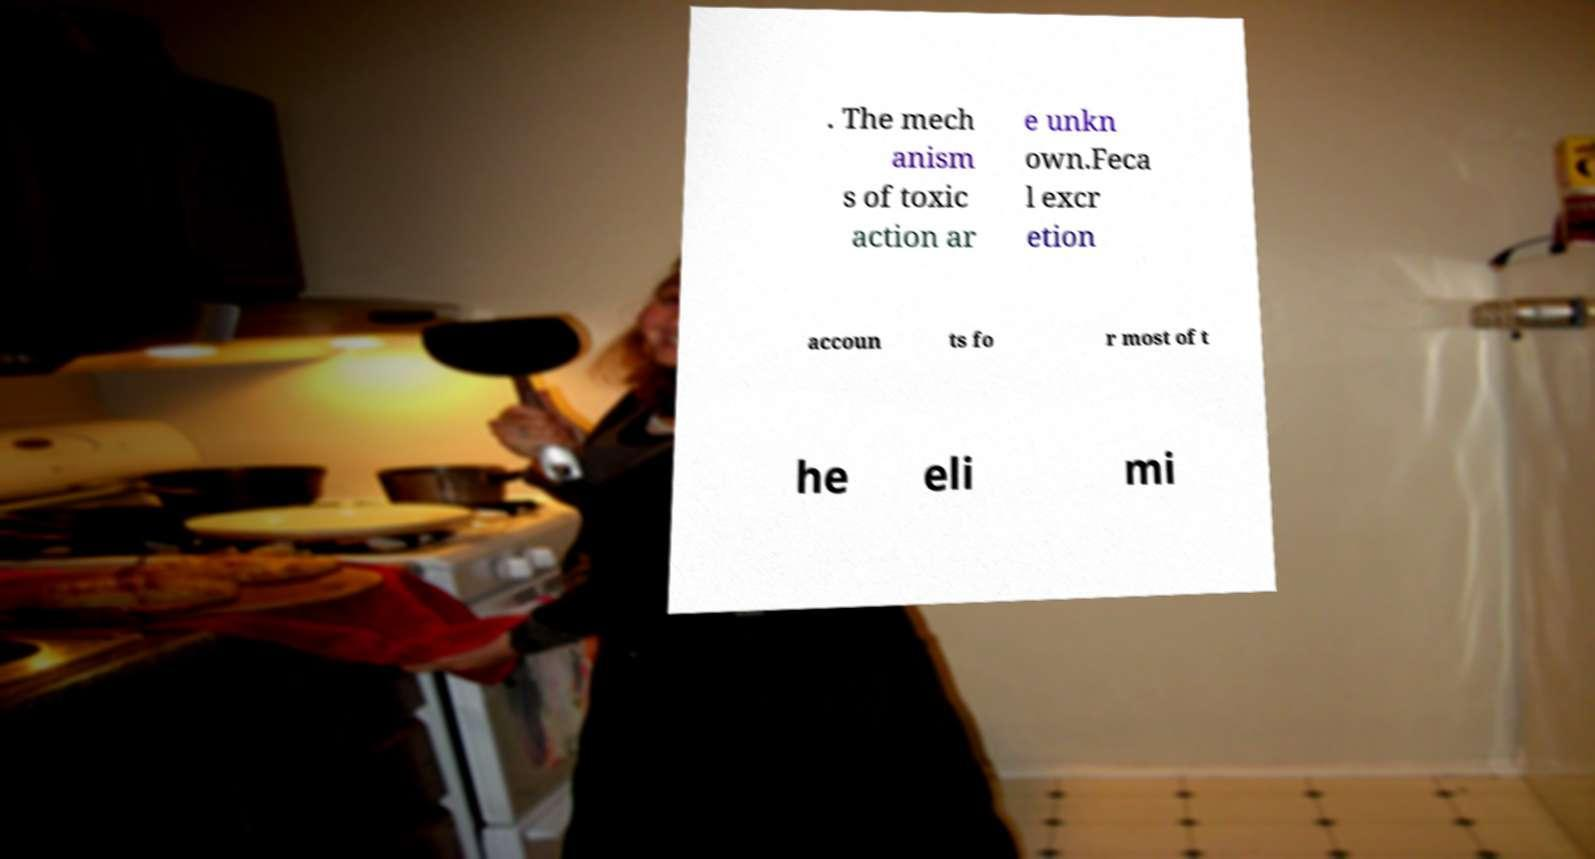Please read and relay the text visible in this image. What does it say? . The mech anism s of toxic action ar e unkn own.Feca l excr etion accoun ts fo r most of t he eli mi 